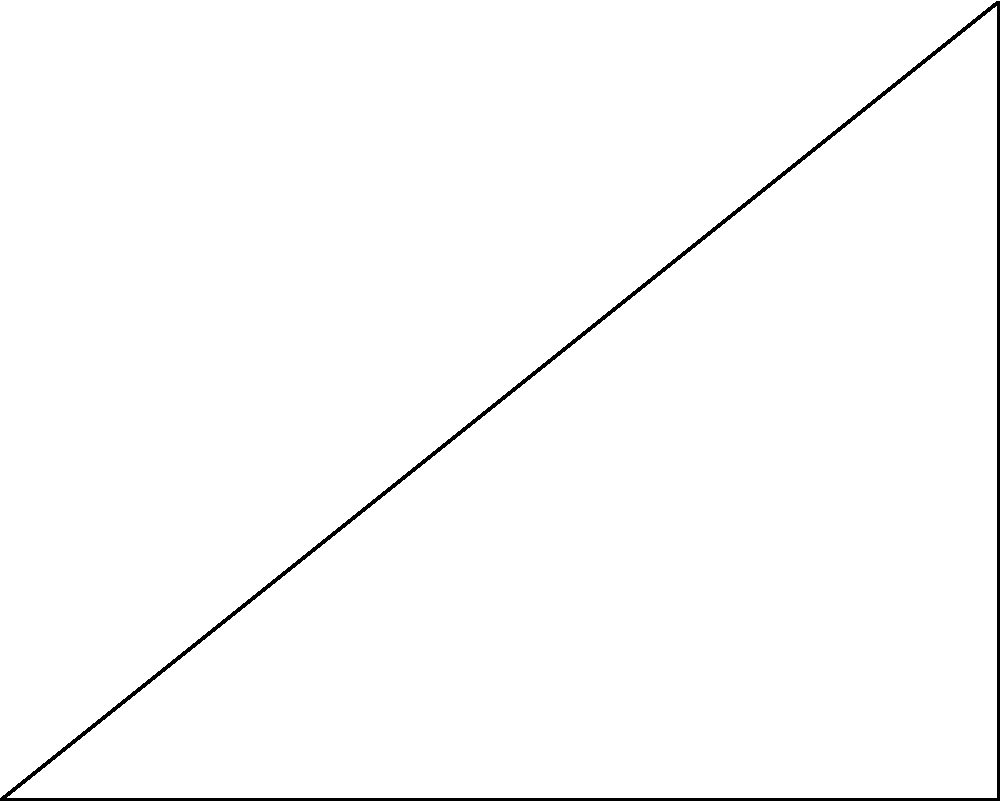In a right-angled triangle ABC, where the right angle is at B, the lengths of the sides are x, y, and z as shown in the figure. If the geometric mean of x and z is equal to y, prove that this property is always true for any right-angled triangle. How does this relate to organizational structures and decision-making processes? Let's approach this step-by-step:

1) The geometric mean of x and z being equal to y can be expressed as:
   $$\sqrt{xz} = y$$

2) Squaring both sides:
   $$xz = y^2$$

3) In a right-angled triangle, by the Pythagorean theorem:
   $$x^2 + y^2 = z^2$$

4) Rearranging the Pythagorean theorem:
   $$y^2 = z^2 - x^2$$

5) Factoring the right side:
   $$y^2 = (z+x)(z-x)$$

6) But we know from step 2 that $y^2 = xz$, so:
   $$xz = (z+x)(z-x)$$

7) Expanding the right side:
   $$xz = z^2 - x^2$$

8) This is always true for any values of x and z.

This property, known as the geometric mean theorem, is always true for right-angled triangles.

Relating to organizational structures:
- The geometric mean represents a balance between extremes, much like how effective organizations balance different aspects (e.g., efficiency and innovation).
- The right angle represents a clear, structured relationship, similar to well-defined organizational hierarchies.
- The interdependence of the sides mirrors how different departments or functions in an organization are interconnected and must work in harmony.
- The theorem's universality suggests that certain organizational principles may be universally applicable, regardless of the specific context or scale of the organization.
Answer: The geometric mean property is always true for right triangles due to the Pythagorean theorem. It relates to organizational balance, structure, interdependence, and universal principles. 